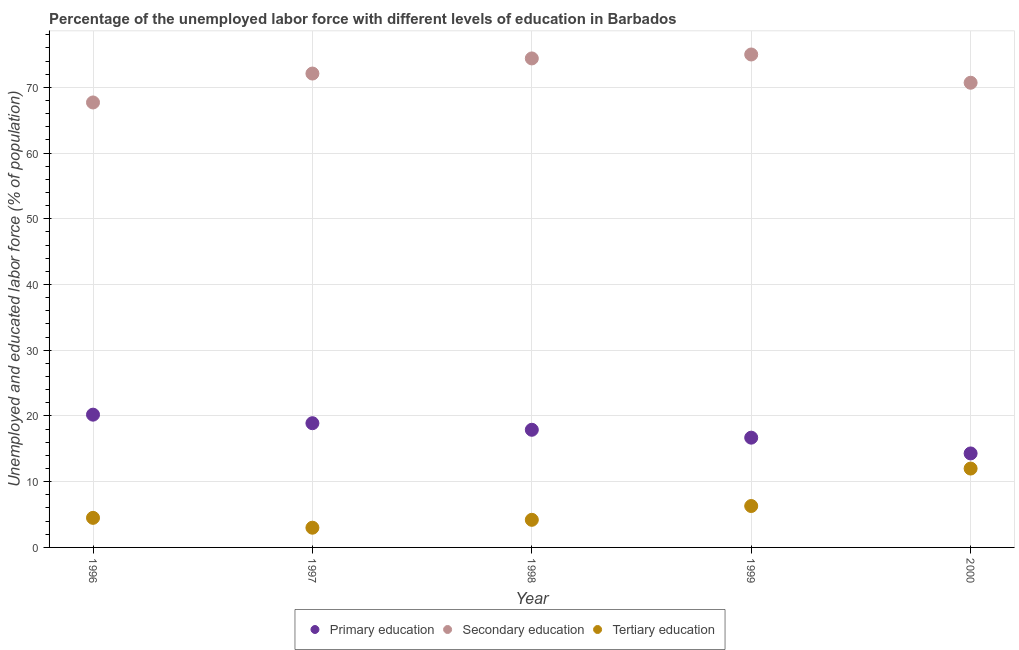Is the number of dotlines equal to the number of legend labels?
Provide a succinct answer. Yes. What is the percentage of labor force who received tertiary education in 1999?
Your response must be concise. 6.3. Across all years, what is the maximum percentage of labor force who received primary education?
Keep it short and to the point. 20.2. Across all years, what is the minimum percentage of labor force who received primary education?
Your answer should be compact. 14.3. What is the total percentage of labor force who received primary education in the graph?
Offer a terse response. 88. What is the difference between the percentage of labor force who received tertiary education in 1999 and that in 2000?
Offer a very short reply. -5.7. What is the difference between the percentage of labor force who received primary education in 1999 and the percentage of labor force who received tertiary education in 2000?
Make the answer very short. 4.7. In the year 1996, what is the difference between the percentage of labor force who received secondary education and percentage of labor force who received primary education?
Keep it short and to the point. 47.5. What is the ratio of the percentage of labor force who received tertiary education in 1998 to that in 2000?
Provide a succinct answer. 0.35. Is the percentage of labor force who received secondary education in 1996 less than that in 1997?
Your answer should be very brief. Yes. What is the difference between the highest and the second highest percentage of labor force who received primary education?
Your answer should be very brief. 1.3. What is the difference between the highest and the lowest percentage of labor force who received primary education?
Your answer should be compact. 5.9. In how many years, is the percentage of labor force who received tertiary education greater than the average percentage of labor force who received tertiary education taken over all years?
Keep it short and to the point. 2. Is the sum of the percentage of labor force who received tertiary education in 1997 and 1998 greater than the maximum percentage of labor force who received secondary education across all years?
Your answer should be compact. No. Is it the case that in every year, the sum of the percentage of labor force who received primary education and percentage of labor force who received secondary education is greater than the percentage of labor force who received tertiary education?
Make the answer very short. Yes. Is the percentage of labor force who received primary education strictly greater than the percentage of labor force who received secondary education over the years?
Make the answer very short. No. How many dotlines are there?
Provide a succinct answer. 3. How many years are there in the graph?
Your answer should be compact. 5. Are the values on the major ticks of Y-axis written in scientific E-notation?
Your response must be concise. No. Does the graph contain any zero values?
Provide a short and direct response. No. Does the graph contain grids?
Ensure brevity in your answer.  Yes. How many legend labels are there?
Provide a short and direct response. 3. How are the legend labels stacked?
Your response must be concise. Horizontal. What is the title of the graph?
Keep it short and to the point. Percentage of the unemployed labor force with different levels of education in Barbados. What is the label or title of the Y-axis?
Offer a very short reply. Unemployed and educated labor force (% of population). What is the Unemployed and educated labor force (% of population) in Primary education in 1996?
Your answer should be compact. 20.2. What is the Unemployed and educated labor force (% of population) in Secondary education in 1996?
Offer a terse response. 67.7. What is the Unemployed and educated labor force (% of population) of Tertiary education in 1996?
Keep it short and to the point. 4.5. What is the Unemployed and educated labor force (% of population) in Primary education in 1997?
Ensure brevity in your answer.  18.9. What is the Unemployed and educated labor force (% of population) in Secondary education in 1997?
Give a very brief answer. 72.1. What is the Unemployed and educated labor force (% of population) of Primary education in 1998?
Your response must be concise. 17.9. What is the Unemployed and educated labor force (% of population) in Secondary education in 1998?
Offer a very short reply. 74.4. What is the Unemployed and educated labor force (% of population) in Tertiary education in 1998?
Offer a terse response. 4.2. What is the Unemployed and educated labor force (% of population) in Primary education in 1999?
Ensure brevity in your answer.  16.7. What is the Unemployed and educated labor force (% of population) of Tertiary education in 1999?
Your answer should be very brief. 6.3. What is the Unemployed and educated labor force (% of population) in Primary education in 2000?
Make the answer very short. 14.3. What is the Unemployed and educated labor force (% of population) of Secondary education in 2000?
Your answer should be compact. 70.7. What is the Unemployed and educated labor force (% of population) of Tertiary education in 2000?
Offer a terse response. 12. Across all years, what is the maximum Unemployed and educated labor force (% of population) in Primary education?
Provide a succinct answer. 20.2. Across all years, what is the maximum Unemployed and educated labor force (% of population) in Secondary education?
Offer a very short reply. 75. Across all years, what is the maximum Unemployed and educated labor force (% of population) of Tertiary education?
Offer a terse response. 12. Across all years, what is the minimum Unemployed and educated labor force (% of population) in Primary education?
Keep it short and to the point. 14.3. Across all years, what is the minimum Unemployed and educated labor force (% of population) of Secondary education?
Make the answer very short. 67.7. What is the total Unemployed and educated labor force (% of population) of Primary education in the graph?
Keep it short and to the point. 88. What is the total Unemployed and educated labor force (% of population) in Secondary education in the graph?
Provide a short and direct response. 359.9. What is the total Unemployed and educated labor force (% of population) of Tertiary education in the graph?
Ensure brevity in your answer.  30. What is the difference between the Unemployed and educated labor force (% of population) of Primary education in 1996 and that in 1997?
Your answer should be compact. 1.3. What is the difference between the Unemployed and educated labor force (% of population) of Secondary education in 1996 and that in 1997?
Keep it short and to the point. -4.4. What is the difference between the Unemployed and educated labor force (% of population) of Primary education in 1996 and that in 1998?
Offer a terse response. 2.3. What is the difference between the Unemployed and educated labor force (% of population) in Primary education in 1996 and that in 2000?
Your answer should be very brief. 5.9. What is the difference between the Unemployed and educated labor force (% of population) of Primary education in 1997 and that in 1998?
Give a very brief answer. 1. What is the difference between the Unemployed and educated labor force (% of population) of Primary education in 1997 and that in 1999?
Give a very brief answer. 2.2. What is the difference between the Unemployed and educated labor force (% of population) in Tertiary education in 1997 and that in 1999?
Your answer should be compact. -3.3. What is the difference between the Unemployed and educated labor force (% of population) in Primary education in 1997 and that in 2000?
Your answer should be compact. 4.6. What is the difference between the Unemployed and educated labor force (% of population) of Tertiary education in 1997 and that in 2000?
Your answer should be very brief. -9. What is the difference between the Unemployed and educated labor force (% of population) of Tertiary education in 1998 and that in 1999?
Your answer should be compact. -2.1. What is the difference between the Unemployed and educated labor force (% of population) in Primary education in 1998 and that in 2000?
Your answer should be very brief. 3.6. What is the difference between the Unemployed and educated labor force (% of population) in Secondary education in 1998 and that in 2000?
Provide a succinct answer. 3.7. What is the difference between the Unemployed and educated labor force (% of population) in Tertiary education in 1998 and that in 2000?
Ensure brevity in your answer.  -7.8. What is the difference between the Unemployed and educated labor force (% of population) of Secondary education in 1999 and that in 2000?
Keep it short and to the point. 4.3. What is the difference between the Unemployed and educated labor force (% of population) of Primary education in 1996 and the Unemployed and educated labor force (% of population) of Secondary education in 1997?
Give a very brief answer. -51.9. What is the difference between the Unemployed and educated labor force (% of population) in Primary education in 1996 and the Unemployed and educated labor force (% of population) in Tertiary education in 1997?
Provide a short and direct response. 17.2. What is the difference between the Unemployed and educated labor force (% of population) of Secondary education in 1996 and the Unemployed and educated labor force (% of population) of Tertiary education in 1997?
Provide a succinct answer. 64.7. What is the difference between the Unemployed and educated labor force (% of population) of Primary education in 1996 and the Unemployed and educated labor force (% of population) of Secondary education in 1998?
Offer a terse response. -54.2. What is the difference between the Unemployed and educated labor force (% of population) of Secondary education in 1996 and the Unemployed and educated labor force (% of population) of Tertiary education in 1998?
Provide a short and direct response. 63.5. What is the difference between the Unemployed and educated labor force (% of population) of Primary education in 1996 and the Unemployed and educated labor force (% of population) of Secondary education in 1999?
Provide a short and direct response. -54.8. What is the difference between the Unemployed and educated labor force (% of population) in Secondary education in 1996 and the Unemployed and educated labor force (% of population) in Tertiary education in 1999?
Provide a succinct answer. 61.4. What is the difference between the Unemployed and educated labor force (% of population) of Primary education in 1996 and the Unemployed and educated labor force (% of population) of Secondary education in 2000?
Your answer should be compact. -50.5. What is the difference between the Unemployed and educated labor force (% of population) of Secondary education in 1996 and the Unemployed and educated labor force (% of population) of Tertiary education in 2000?
Your answer should be very brief. 55.7. What is the difference between the Unemployed and educated labor force (% of population) in Primary education in 1997 and the Unemployed and educated labor force (% of population) in Secondary education in 1998?
Offer a terse response. -55.5. What is the difference between the Unemployed and educated labor force (% of population) of Primary education in 1997 and the Unemployed and educated labor force (% of population) of Tertiary education in 1998?
Give a very brief answer. 14.7. What is the difference between the Unemployed and educated labor force (% of population) of Secondary education in 1997 and the Unemployed and educated labor force (% of population) of Tertiary education in 1998?
Ensure brevity in your answer.  67.9. What is the difference between the Unemployed and educated labor force (% of population) of Primary education in 1997 and the Unemployed and educated labor force (% of population) of Secondary education in 1999?
Offer a very short reply. -56.1. What is the difference between the Unemployed and educated labor force (% of population) of Primary education in 1997 and the Unemployed and educated labor force (% of population) of Tertiary education in 1999?
Offer a terse response. 12.6. What is the difference between the Unemployed and educated labor force (% of population) in Secondary education in 1997 and the Unemployed and educated labor force (% of population) in Tertiary education in 1999?
Ensure brevity in your answer.  65.8. What is the difference between the Unemployed and educated labor force (% of population) in Primary education in 1997 and the Unemployed and educated labor force (% of population) in Secondary education in 2000?
Make the answer very short. -51.8. What is the difference between the Unemployed and educated labor force (% of population) of Primary education in 1997 and the Unemployed and educated labor force (% of population) of Tertiary education in 2000?
Your answer should be very brief. 6.9. What is the difference between the Unemployed and educated labor force (% of population) in Secondary education in 1997 and the Unemployed and educated labor force (% of population) in Tertiary education in 2000?
Offer a terse response. 60.1. What is the difference between the Unemployed and educated labor force (% of population) of Primary education in 1998 and the Unemployed and educated labor force (% of population) of Secondary education in 1999?
Ensure brevity in your answer.  -57.1. What is the difference between the Unemployed and educated labor force (% of population) in Secondary education in 1998 and the Unemployed and educated labor force (% of population) in Tertiary education in 1999?
Give a very brief answer. 68.1. What is the difference between the Unemployed and educated labor force (% of population) in Primary education in 1998 and the Unemployed and educated labor force (% of population) in Secondary education in 2000?
Make the answer very short. -52.8. What is the difference between the Unemployed and educated labor force (% of population) in Primary education in 1998 and the Unemployed and educated labor force (% of population) in Tertiary education in 2000?
Make the answer very short. 5.9. What is the difference between the Unemployed and educated labor force (% of population) in Secondary education in 1998 and the Unemployed and educated labor force (% of population) in Tertiary education in 2000?
Your response must be concise. 62.4. What is the difference between the Unemployed and educated labor force (% of population) in Primary education in 1999 and the Unemployed and educated labor force (% of population) in Secondary education in 2000?
Make the answer very short. -54. What is the difference between the Unemployed and educated labor force (% of population) in Primary education in 1999 and the Unemployed and educated labor force (% of population) in Tertiary education in 2000?
Keep it short and to the point. 4.7. What is the difference between the Unemployed and educated labor force (% of population) in Secondary education in 1999 and the Unemployed and educated labor force (% of population) in Tertiary education in 2000?
Your response must be concise. 63. What is the average Unemployed and educated labor force (% of population) of Primary education per year?
Offer a terse response. 17.6. What is the average Unemployed and educated labor force (% of population) of Secondary education per year?
Provide a short and direct response. 71.98. In the year 1996, what is the difference between the Unemployed and educated labor force (% of population) in Primary education and Unemployed and educated labor force (% of population) in Secondary education?
Provide a short and direct response. -47.5. In the year 1996, what is the difference between the Unemployed and educated labor force (% of population) of Secondary education and Unemployed and educated labor force (% of population) of Tertiary education?
Your answer should be very brief. 63.2. In the year 1997, what is the difference between the Unemployed and educated labor force (% of population) of Primary education and Unemployed and educated labor force (% of population) of Secondary education?
Make the answer very short. -53.2. In the year 1997, what is the difference between the Unemployed and educated labor force (% of population) in Secondary education and Unemployed and educated labor force (% of population) in Tertiary education?
Provide a succinct answer. 69.1. In the year 1998, what is the difference between the Unemployed and educated labor force (% of population) in Primary education and Unemployed and educated labor force (% of population) in Secondary education?
Your answer should be very brief. -56.5. In the year 1998, what is the difference between the Unemployed and educated labor force (% of population) of Secondary education and Unemployed and educated labor force (% of population) of Tertiary education?
Offer a terse response. 70.2. In the year 1999, what is the difference between the Unemployed and educated labor force (% of population) in Primary education and Unemployed and educated labor force (% of population) in Secondary education?
Offer a terse response. -58.3. In the year 1999, what is the difference between the Unemployed and educated labor force (% of population) in Primary education and Unemployed and educated labor force (% of population) in Tertiary education?
Provide a short and direct response. 10.4. In the year 1999, what is the difference between the Unemployed and educated labor force (% of population) of Secondary education and Unemployed and educated labor force (% of population) of Tertiary education?
Your answer should be compact. 68.7. In the year 2000, what is the difference between the Unemployed and educated labor force (% of population) in Primary education and Unemployed and educated labor force (% of population) in Secondary education?
Keep it short and to the point. -56.4. In the year 2000, what is the difference between the Unemployed and educated labor force (% of population) of Primary education and Unemployed and educated labor force (% of population) of Tertiary education?
Offer a very short reply. 2.3. In the year 2000, what is the difference between the Unemployed and educated labor force (% of population) in Secondary education and Unemployed and educated labor force (% of population) in Tertiary education?
Ensure brevity in your answer.  58.7. What is the ratio of the Unemployed and educated labor force (% of population) in Primary education in 1996 to that in 1997?
Your answer should be compact. 1.07. What is the ratio of the Unemployed and educated labor force (% of population) in Secondary education in 1996 to that in 1997?
Ensure brevity in your answer.  0.94. What is the ratio of the Unemployed and educated labor force (% of population) in Tertiary education in 1996 to that in 1997?
Keep it short and to the point. 1.5. What is the ratio of the Unemployed and educated labor force (% of population) in Primary education in 1996 to that in 1998?
Provide a succinct answer. 1.13. What is the ratio of the Unemployed and educated labor force (% of population) of Secondary education in 1996 to that in 1998?
Provide a succinct answer. 0.91. What is the ratio of the Unemployed and educated labor force (% of population) of Tertiary education in 1996 to that in 1998?
Your answer should be very brief. 1.07. What is the ratio of the Unemployed and educated labor force (% of population) in Primary education in 1996 to that in 1999?
Provide a short and direct response. 1.21. What is the ratio of the Unemployed and educated labor force (% of population) of Secondary education in 1996 to that in 1999?
Keep it short and to the point. 0.9. What is the ratio of the Unemployed and educated labor force (% of population) in Primary education in 1996 to that in 2000?
Make the answer very short. 1.41. What is the ratio of the Unemployed and educated labor force (% of population) of Secondary education in 1996 to that in 2000?
Offer a terse response. 0.96. What is the ratio of the Unemployed and educated labor force (% of population) in Tertiary education in 1996 to that in 2000?
Provide a succinct answer. 0.38. What is the ratio of the Unemployed and educated labor force (% of population) of Primary education in 1997 to that in 1998?
Your answer should be compact. 1.06. What is the ratio of the Unemployed and educated labor force (% of population) of Secondary education in 1997 to that in 1998?
Provide a short and direct response. 0.97. What is the ratio of the Unemployed and educated labor force (% of population) of Tertiary education in 1997 to that in 1998?
Your answer should be compact. 0.71. What is the ratio of the Unemployed and educated labor force (% of population) of Primary education in 1997 to that in 1999?
Your response must be concise. 1.13. What is the ratio of the Unemployed and educated labor force (% of population) in Secondary education in 1997 to that in 1999?
Offer a terse response. 0.96. What is the ratio of the Unemployed and educated labor force (% of population) of Tertiary education in 1997 to that in 1999?
Give a very brief answer. 0.48. What is the ratio of the Unemployed and educated labor force (% of population) in Primary education in 1997 to that in 2000?
Ensure brevity in your answer.  1.32. What is the ratio of the Unemployed and educated labor force (% of population) in Secondary education in 1997 to that in 2000?
Make the answer very short. 1.02. What is the ratio of the Unemployed and educated labor force (% of population) of Primary education in 1998 to that in 1999?
Your answer should be very brief. 1.07. What is the ratio of the Unemployed and educated labor force (% of population) in Primary education in 1998 to that in 2000?
Give a very brief answer. 1.25. What is the ratio of the Unemployed and educated labor force (% of population) of Secondary education in 1998 to that in 2000?
Give a very brief answer. 1.05. What is the ratio of the Unemployed and educated labor force (% of population) of Primary education in 1999 to that in 2000?
Keep it short and to the point. 1.17. What is the ratio of the Unemployed and educated labor force (% of population) in Secondary education in 1999 to that in 2000?
Offer a terse response. 1.06. What is the ratio of the Unemployed and educated labor force (% of population) in Tertiary education in 1999 to that in 2000?
Keep it short and to the point. 0.53. 